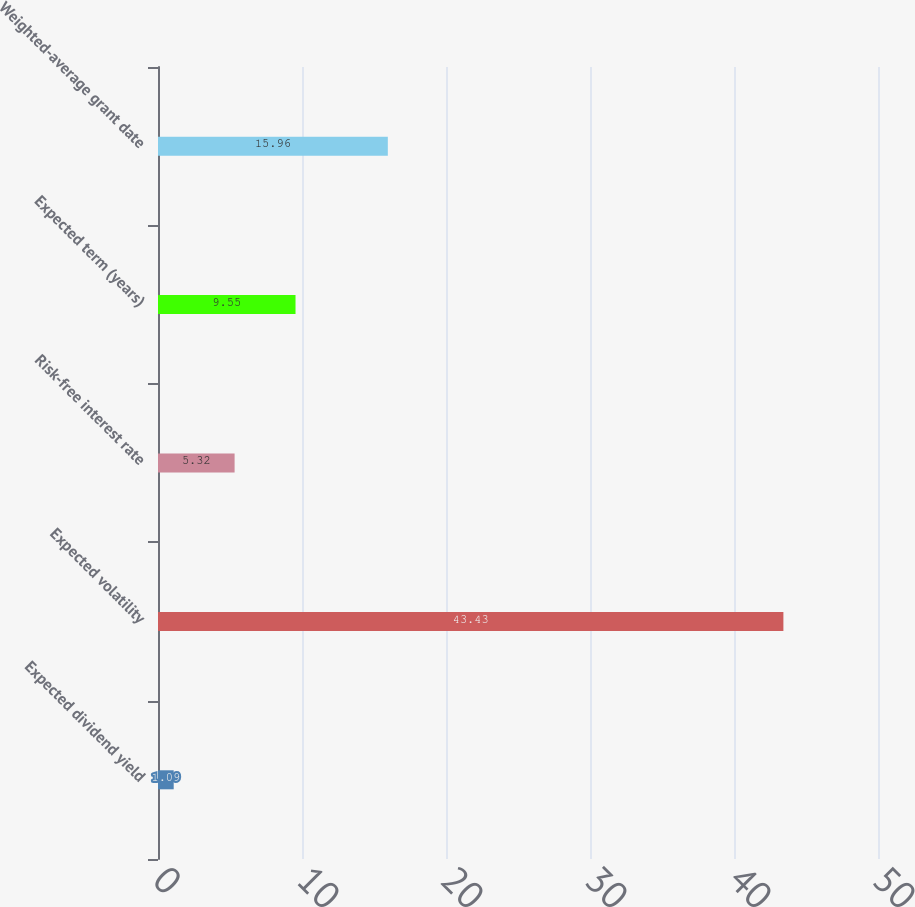Convert chart. <chart><loc_0><loc_0><loc_500><loc_500><bar_chart><fcel>Expected dividend yield<fcel>Expected volatility<fcel>Risk-free interest rate<fcel>Expected term (years)<fcel>Weighted-average grant date<nl><fcel>1.09<fcel>43.43<fcel>5.32<fcel>9.55<fcel>15.96<nl></chart> 